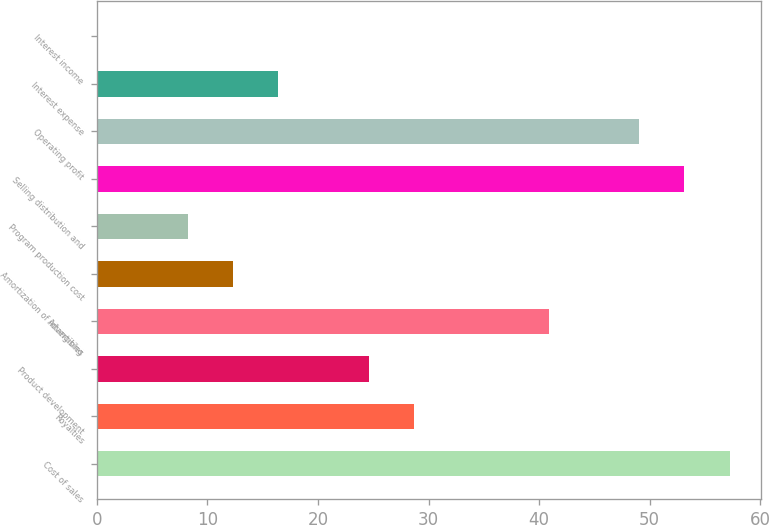Convert chart. <chart><loc_0><loc_0><loc_500><loc_500><bar_chart><fcel>Cost of sales<fcel>Royalties<fcel>Product development<fcel>Advertising<fcel>Amortization of intangibles<fcel>Program production cost<fcel>Selling distribution and<fcel>Operating profit<fcel>Interest expense<fcel>Interest income<nl><fcel>57.22<fcel>28.66<fcel>24.58<fcel>40.9<fcel>12.34<fcel>8.26<fcel>53.14<fcel>49.06<fcel>16.42<fcel>0.1<nl></chart> 